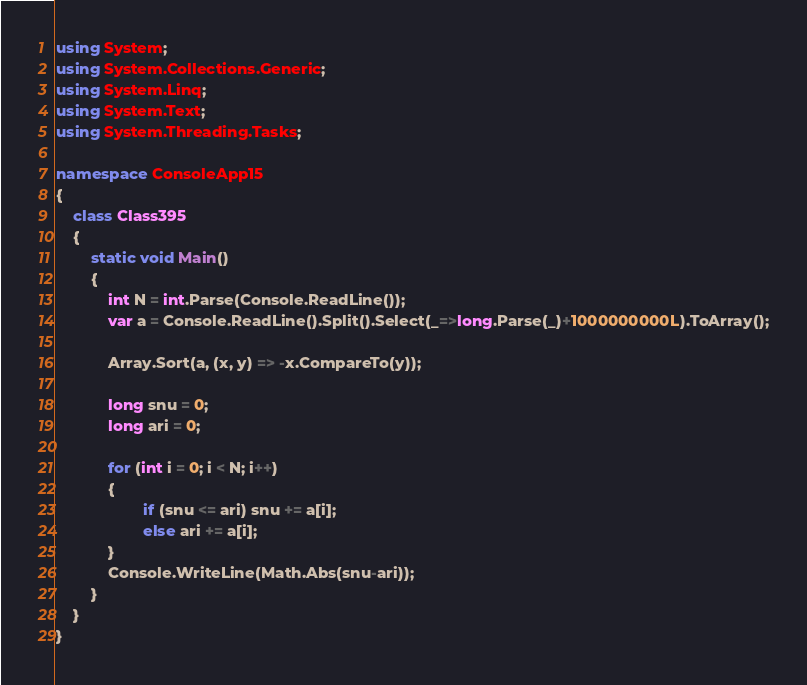Convert code to text. <code><loc_0><loc_0><loc_500><loc_500><_C#_>using System;
using System.Collections.Generic;
using System.Linq;
using System.Text;
using System.Threading.Tasks;

namespace ConsoleApp15
{
    class Class395
    {
        static void Main()
        {
            int N = int.Parse(Console.ReadLine());
            var a = Console.ReadLine().Split().Select(_=>long.Parse(_)+1000000000L).ToArray();

            Array.Sort(a, (x, y) => -x.CompareTo(y));

            long snu = 0;
            long ari = 0;

            for (int i = 0; i < N; i++)
            {
                    if (snu <= ari) snu += a[i];
                    else ari += a[i];   
            }
            Console.WriteLine(Math.Abs(snu-ari));
        }
    }
}
</code> 